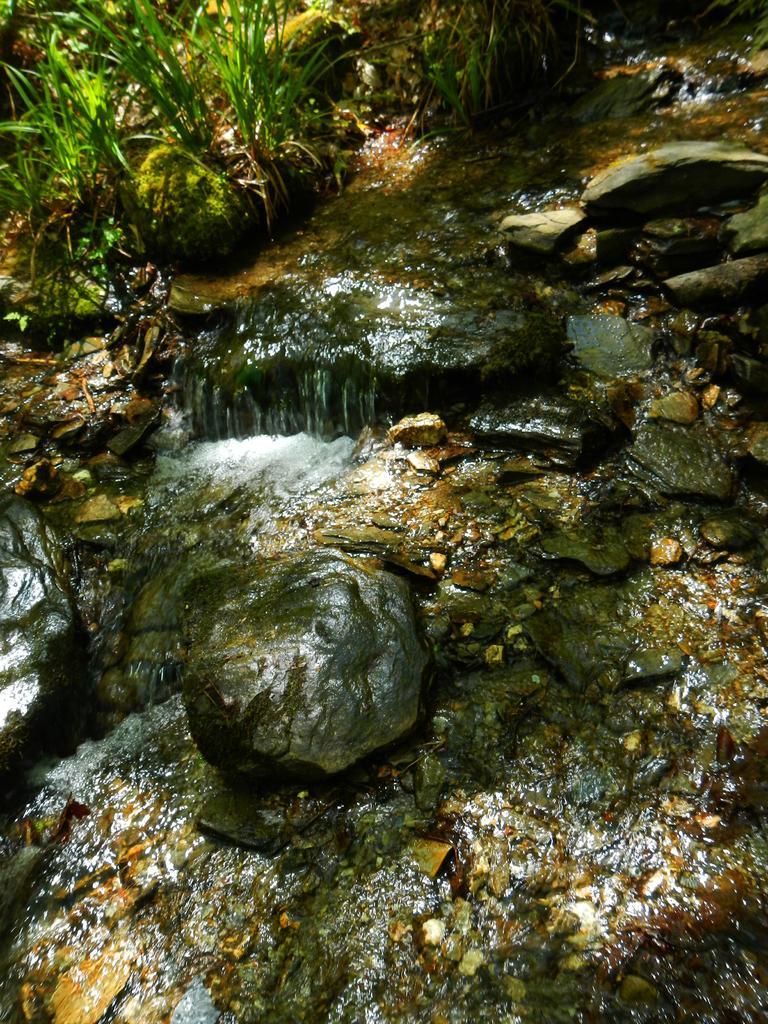Can you describe this image briefly? In the picture I can see the rocks and water. I can see the plants on the top left side of the picture. 